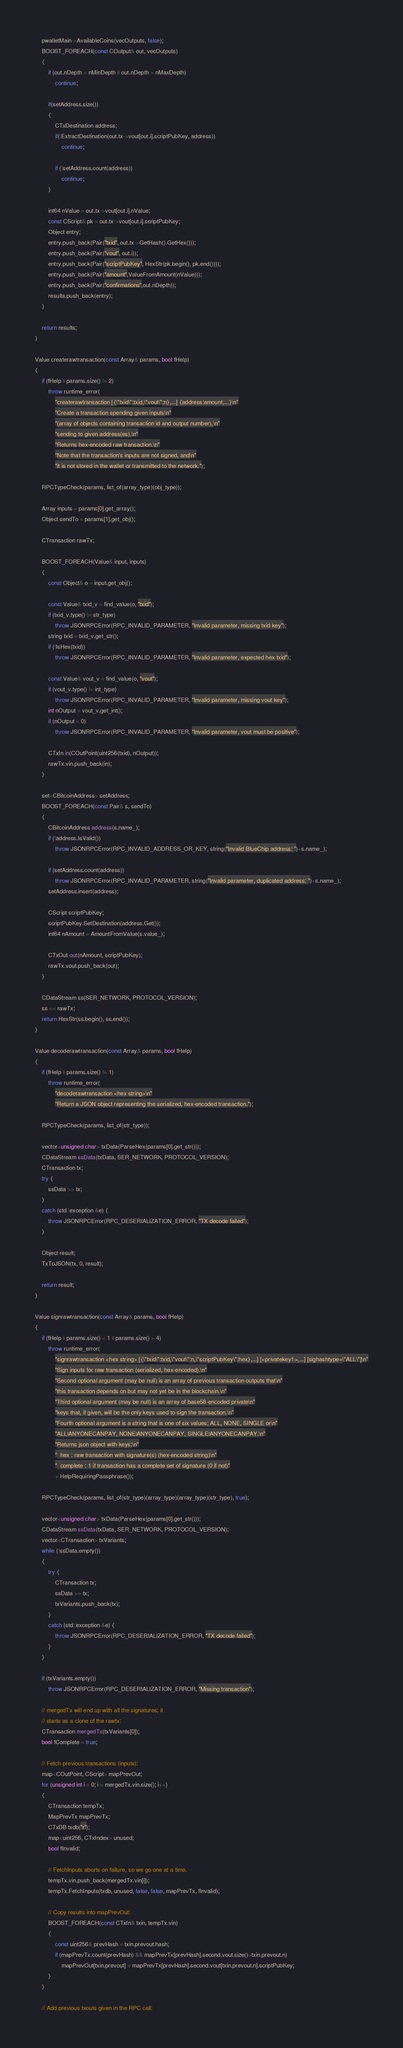Convert code to text. <code><loc_0><loc_0><loc_500><loc_500><_C++_>    pwalletMain->AvailableCoins(vecOutputs, false);
    BOOST_FOREACH(const COutput& out, vecOutputs)
    {
        if (out.nDepth < nMinDepth || out.nDepth > nMaxDepth)
            continue;

        if(setAddress.size())
        {
            CTxDestination address;
            if(!ExtractDestination(out.tx->vout[out.i].scriptPubKey, address))
                continue;

            if (!setAddress.count(address))
                continue;
        }

        int64 nValue = out.tx->vout[out.i].nValue;
        const CScript& pk = out.tx->vout[out.i].scriptPubKey;
        Object entry;
        entry.push_back(Pair("txid", out.tx->GetHash().GetHex()));
        entry.push_back(Pair("vout", out.i));
        entry.push_back(Pair("scriptPubKey", HexStr(pk.begin(), pk.end())));
        entry.push_back(Pair("amount",ValueFromAmount(nValue)));
        entry.push_back(Pair("confirmations",out.nDepth));
        results.push_back(entry);
    }

    return results;
}

Value createrawtransaction(const Array& params, bool fHelp)
{
    if (fHelp || params.size() != 2)
        throw runtime_error(
            "createrawtransaction [{\"txid\":txid,\"vout\":n},...] {address:amount,...}\n"
            "Create a transaction spending given inputs\n"
            "(array of objects containing transaction id and output number),\n"
            "sending to given address(es).\n"
            "Returns hex-encoded raw transaction.\n"
            "Note that the transaction's inputs are not signed, and\n"
            "it is not stored in the wallet or transmitted to the network.");

    RPCTypeCheck(params, list_of(array_type)(obj_type));

    Array inputs = params[0].get_array();
    Object sendTo = params[1].get_obj();

    CTransaction rawTx;

    BOOST_FOREACH(Value& input, inputs)
    {
        const Object& o = input.get_obj();

        const Value& txid_v = find_value(o, "txid");
        if (txid_v.type() != str_type)
            throw JSONRPCError(RPC_INVALID_PARAMETER, "Invalid parameter, missing txid key");
        string txid = txid_v.get_str();
        if (!IsHex(txid))
            throw JSONRPCError(RPC_INVALID_PARAMETER, "Invalid parameter, expected hex txid");

        const Value& vout_v = find_value(o, "vout");
        if (vout_v.type() != int_type)
            throw JSONRPCError(RPC_INVALID_PARAMETER, "Invalid parameter, missing vout key");
        int nOutput = vout_v.get_int();
        if (nOutput < 0)
            throw JSONRPCError(RPC_INVALID_PARAMETER, "Invalid parameter, vout must be positive");

        CTxIn in(COutPoint(uint256(txid), nOutput));
        rawTx.vin.push_back(in);
    }

    set<CBitcoinAddress> setAddress;
    BOOST_FOREACH(const Pair& s, sendTo)
    {
        CBitcoinAddress address(s.name_);
        if (!address.IsValid())
            throw JSONRPCError(RPC_INVALID_ADDRESS_OR_KEY, string("Invalid BlueChip address: ")+s.name_);

        if (setAddress.count(address))
            throw JSONRPCError(RPC_INVALID_PARAMETER, string("Invalid parameter, duplicated address: ")+s.name_);
        setAddress.insert(address);

        CScript scriptPubKey;
        scriptPubKey.SetDestination(address.Get());
        int64 nAmount = AmountFromValue(s.value_);

        CTxOut out(nAmount, scriptPubKey);
        rawTx.vout.push_back(out);
    }

    CDataStream ss(SER_NETWORK, PROTOCOL_VERSION);
    ss << rawTx;
    return HexStr(ss.begin(), ss.end());
}

Value decoderawtransaction(const Array& params, bool fHelp)
{
    if (fHelp || params.size() != 1)
        throw runtime_error(
            "decoderawtransaction <hex string>\n"
            "Return a JSON object representing the serialized, hex-encoded transaction.");

    RPCTypeCheck(params, list_of(str_type));

    vector<unsigned char> txData(ParseHex(params[0].get_str()));
    CDataStream ssData(txData, SER_NETWORK, PROTOCOL_VERSION);
    CTransaction tx;
    try {
        ssData >> tx;
    }
    catch (std::exception &e) {
        throw JSONRPCError(RPC_DESERIALIZATION_ERROR, "TX decode failed");
    }

    Object result;
    TxToJSON(tx, 0, result);

    return result;
}

Value signrawtransaction(const Array& params, bool fHelp)
{
    if (fHelp || params.size() < 1 || params.size() > 4)
        throw runtime_error(
            "signrawtransaction <hex string> [{\"txid\":txid,\"vout\":n,\"scriptPubKey\":hex},...] [<privatekey1>,...] [sighashtype=\"ALL\"]\n"
            "Sign inputs for raw transaction (serialized, hex-encoded).\n"
            "Second optional argument (may be null) is an array of previous transaction outputs that\n"
            "this transaction depends on but may not yet be in the blockchain.\n"
            "Third optional argument (may be null) is an array of base58-encoded private\n"
            "keys that, if given, will be the only keys used to sign the transaction.\n"
            "Fourth optional argument is a string that is one of six values; ALL, NONE, SINGLE or\n"
            "ALL|ANYONECANPAY, NONE|ANYONECANPAY, SINGLE|ANYONECANPAY.\n"
            "Returns json object with keys:\n"
            "  hex : raw transaction with signature(s) (hex-encoded string)\n"
            "  complete : 1 if transaction has a complete set of signature (0 if not)"
            + HelpRequiringPassphrase());

    RPCTypeCheck(params, list_of(str_type)(array_type)(array_type)(str_type), true);

    vector<unsigned char> txData(ParseHex(params[0].get_str()));
    CDataStream ssData(txData, SER_NETWORK, PROTOCOL_VERSION);
    vector<CTransaction> txVariants;
    while (!ssData.empty())
    {
        try {
            CTransaction tx;
            ssData >> tx;
            txVariants.push_back(tx);
        }
        catch (std::exception &e) {
            throw JSONRPCError(RPC_DESERIALIZATION_ERROR, "TX decode failed");
        }
    }

    if (txVariants.empty())
        throw JSONRPCError(RPC_DESERIALIZATION_ERROR, "Missing transaction");

    // mergedTx will end up with all the signatures; it
    // starts as a clone of the rawtx:
    CTransaction mergedTx(txVariants[0]);
    bool fComplete = true;

    // Fetch previous transactions (inputs):
    map<COutPoint, CScript> mapPrevOut;
    for (unsigned int i = 0; i < mergedTx.vin.size(); i++)
    {
        CTransaction tempTx;
        MapPrevTx mapPrevTx;
        CTxDB txdb("r");
        map<uint256, CTxIndex> unused;
        bool fInvalid;

        // FetchInputs aborts on failure, so we go one at a time.
        tempTx.vin.push_back(mergedTx.vin[i]);
        tempTx.FetchInputs(txdb, unused, false, false, mapPrevTx, fInvalid);

        // Copy results into mapPrevOut:
        BOOST_FOREACH(const CTxIn& txin, tempTx.vin)
        {
            const uint256& prevHash = txin.prevout.hash;
            if (mapPrevTx.count(prevHash) && mapPrevTx[prevHash].second.vout.size()>txin.prevout.n)
                mapPrevOut[txin.prevout] = mapPrevTx[prevHash].second.vout[txin.prevout.n].scriptPubKey;
        }
    }

    // Add previous txouts given in the RPC call:</code> 